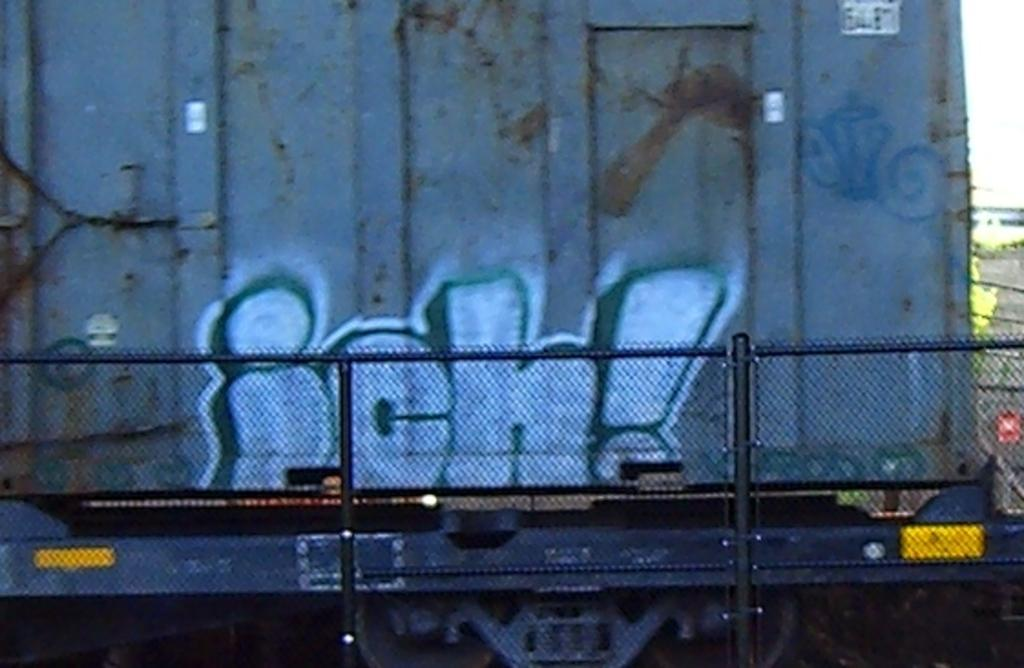Provide a one-sentence caption for the provided image. The back of the truck has "ich!" written on the back in blue and white spray paint. 